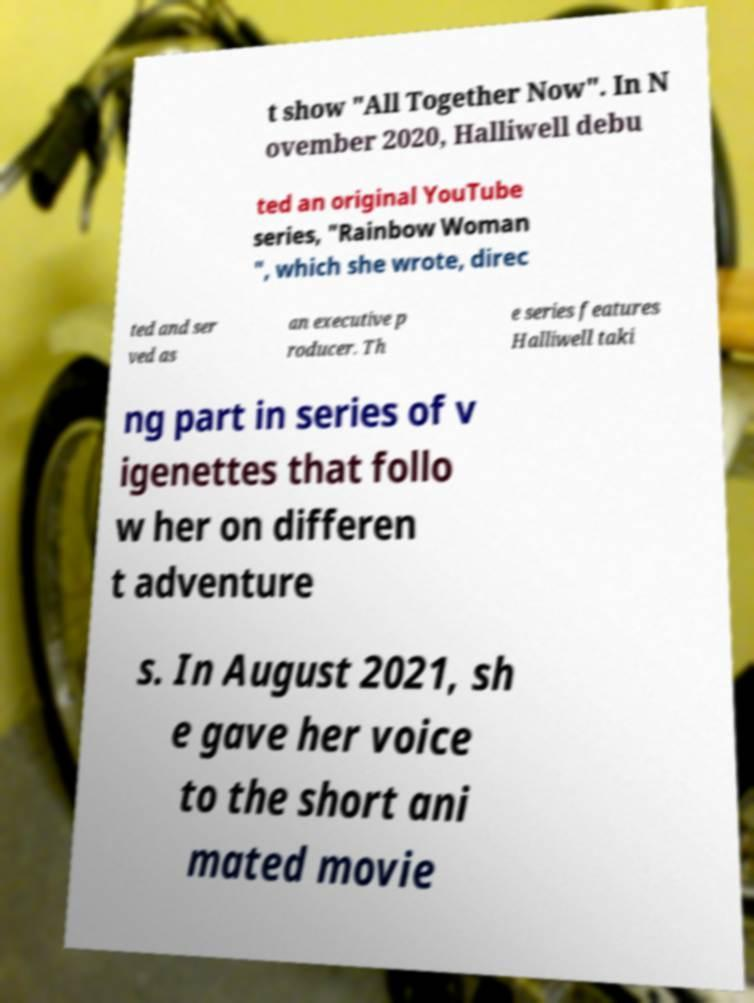Can you accurately transcribe the text from the provided image for me? t show "All Together Now". In N ovember 2020, Halliwell debu ted an original YouTube series, "Rainbow Woman ", which she wrote, direc ted and ser ved as an executive p roducer. Th e series features Halliwell taki ng part in series of v igenettes that follo w her on differen t adventure s. In August 2021, sh e gave her voice to the short ani mated movie 